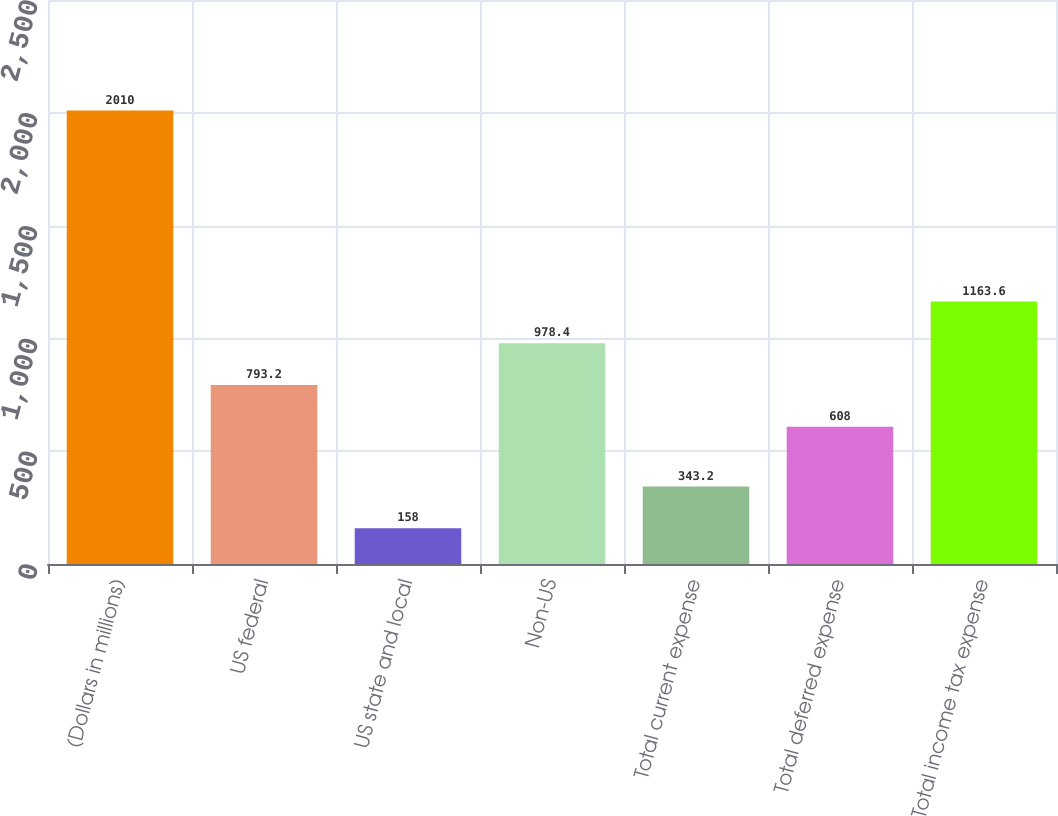<chart> <loc_0><loc_0><loc_500><loc_500><bar_chart><fcel>(Dollars in millions)<fcel>US federal<fcel>US state and local<fcel>Non-US<fcel>Total current expense<fcel>Total deferred expense<fcel>Total income tax expense<nl><fcel>2010<fcel>793.2<fcel>158<fcel>978.4<fcel>343.2<fcel>608<fcel>1163.6<nl></chart> 